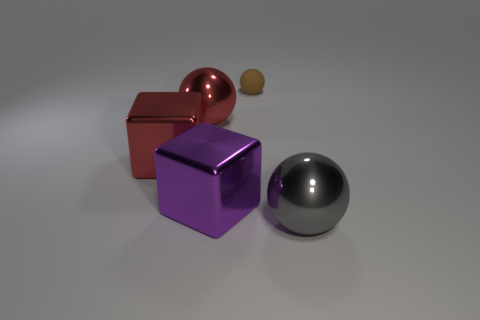How many large things are red metallic objects or rubber things? In the image, there is a large red metallic cube, which counts as one object fitting the description of 'large things that are red metallic'. Additionally, there are other objects present; however, without more information, it is unclear if the other colored objects are made of rubber or not. Assuming none of the other objects are rubber, the answer would remain one. The previous answer of '2' might refer to another object being potentially rubber-based, perhaps the small brown sphere, without specification of size in the definition of 'large things'. This would need clarification for a more accurate response. 